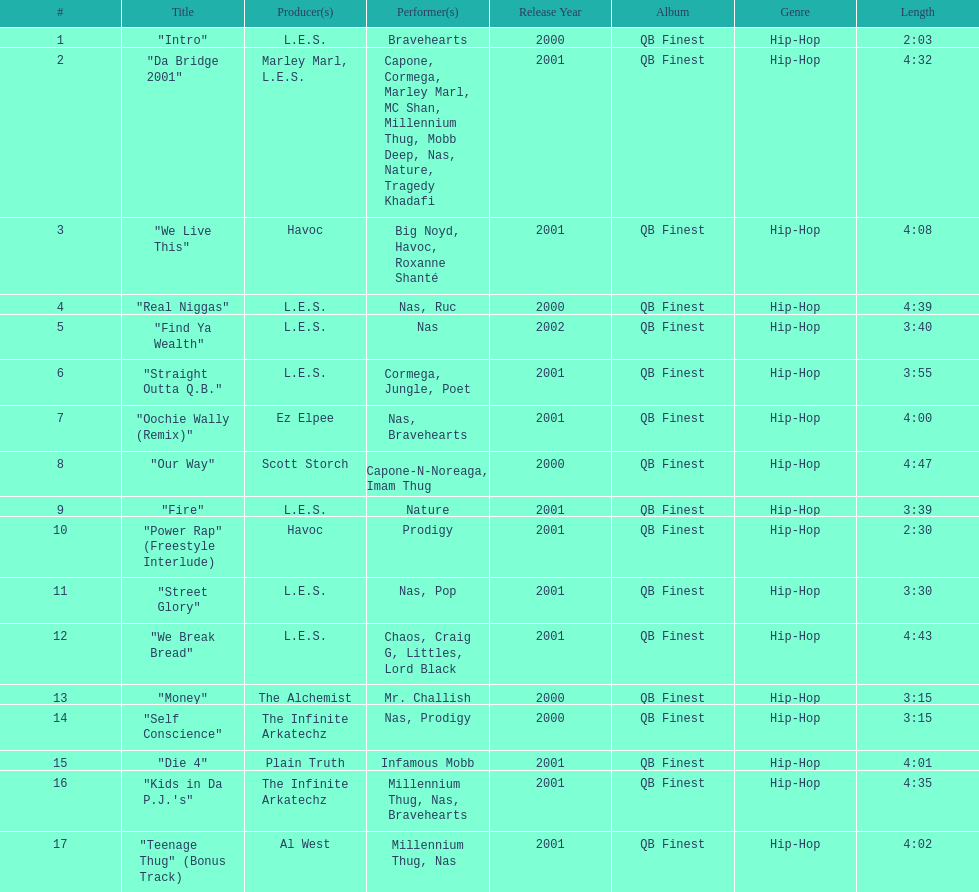How long is the shortest song on the album? 2:03. 